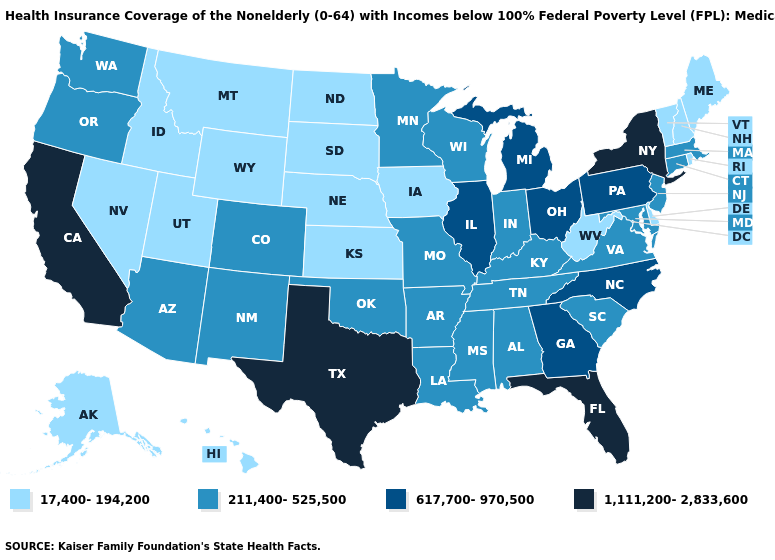Among the states that border Georgia , which have the lowest value?
Write a very short answer. Alabama, South Carolina, Tennessee. Which states have the lowest value in the USA?
Be succinct. Alaska, Delaware, Hawaii, Idaho, Iowa, Kansas, Maine, Montana, Nebraska, Nevada, New Hampshire, North Dakota, Rhode Island, South Dakota, Utah, Vermont, West Virginia, Wyoming. Name the states that have a value in the range 211,400-525,500?
Short answer required. Alabama, Arizona, Arkansas, Colorado, Connecticut, Indiana, Kentucky, Louisiana, Maryland, Massachusetts, Minnesota, Mississippi, Missouri, New Jersey, New Mexico, Oklahoma, Oregon, South Carolina, Tennessee, Virginia, Washington, Wisconsin. Is the legend a continuous bar?
Concise answer only. No. What is the value of Nevada?
Concise answer only. 17,400-194,200. Name the states that have a value in the range 1,111,200-2,833,600?
Write a very short answer. California, Florida, New York, Texas. Which states have the lowest value in the USA?
Concise answer only. Alaska, Delaware, Hawaii, Idaho, Iowa, Kansas, Maine, Montana, Nebraska, Nevada, New Hampshire, North Dakota, Rhode Island, South Dakota, Utah, Vermont, West Virginia, Wyoming. Which states hav the highest value in the South?
Short answer required. Florida, Texas. What is the highest value in the Northeast ?
Write a very short answer. 1,111,200-2,833,600. Name the states that have a value in the range 211,400-525,500?
Quick response, please. Alabama, Arizona, Arkansas, Colorado, Connecticut, Indiana, Kentucky, Louisiana, Maryland, Massachusetts, Minnesota, Mississippi, Missouri, New Jersey, New Mexico, Oklahoma, Oregon, South Carolina, Tennessee, Virginia, Washington, Wisconsin. Which states hav the highest value in the West?
Answer briefly. California. How many symbols are there in the legend?
Write a very short answer. 4. Does Massachusetts have the same value as Wisconsin?
Short answer required. Yes. Name the states that have a value in the range 617,700-970,500?
Write a very short answer. Georgia, Illinois, Michigan, North Carolina, Ohio, Pennsylvania. Is the legend a continuous bar?
Give a very brief answer. No. 